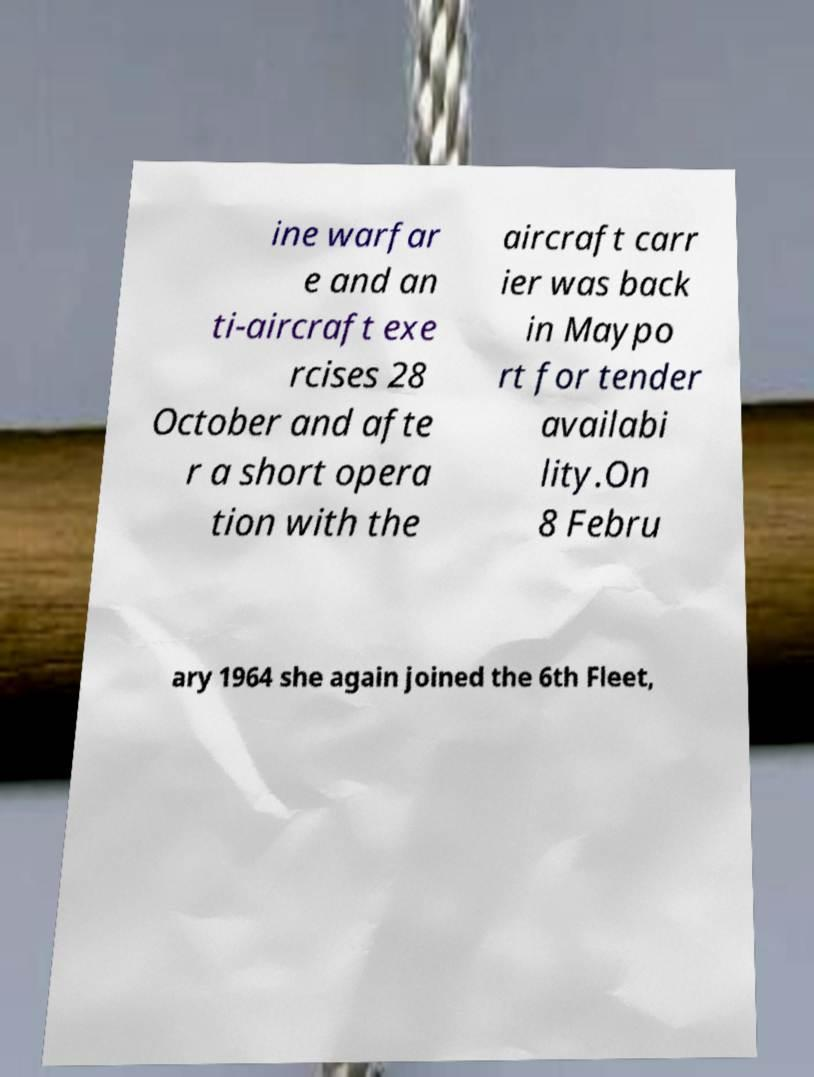Please read and relay the text visible in this image. What does it say? ine warfar e and an ti-aircraft exe rcises 28 October and afte r a short opera tion with the aircraft carr ier was back in Maypo rt for tender availabi lity.On 8 Febru ary 1964 she again joined the 6th Fleet, 